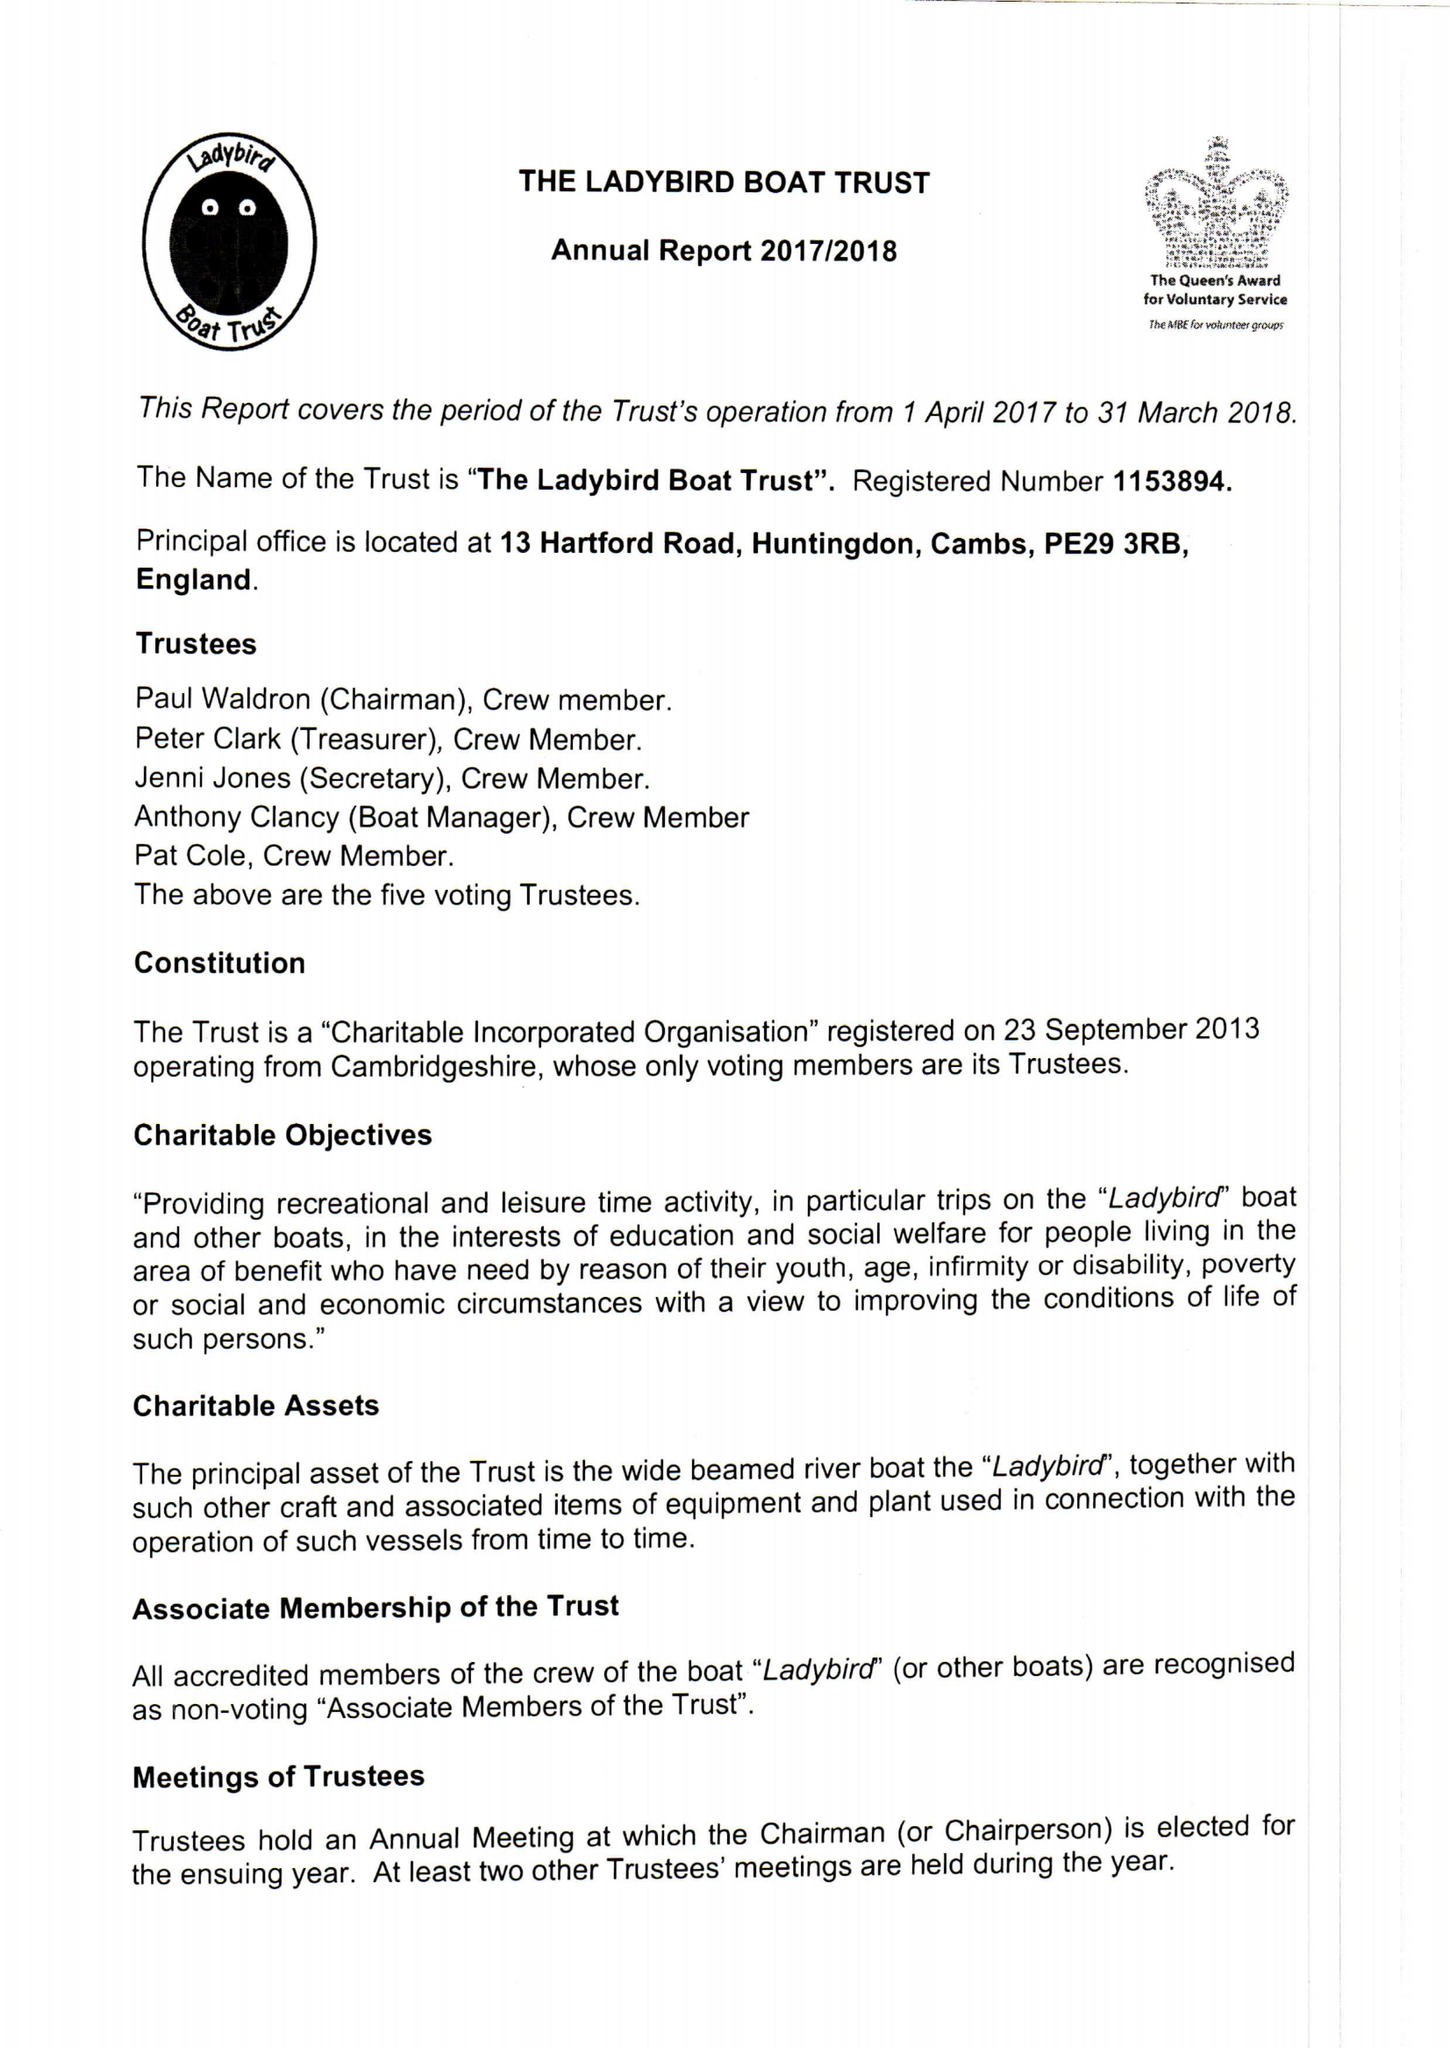What is the value for the report_date?
Answer the question using a single word or phrase. 2018-03-31 